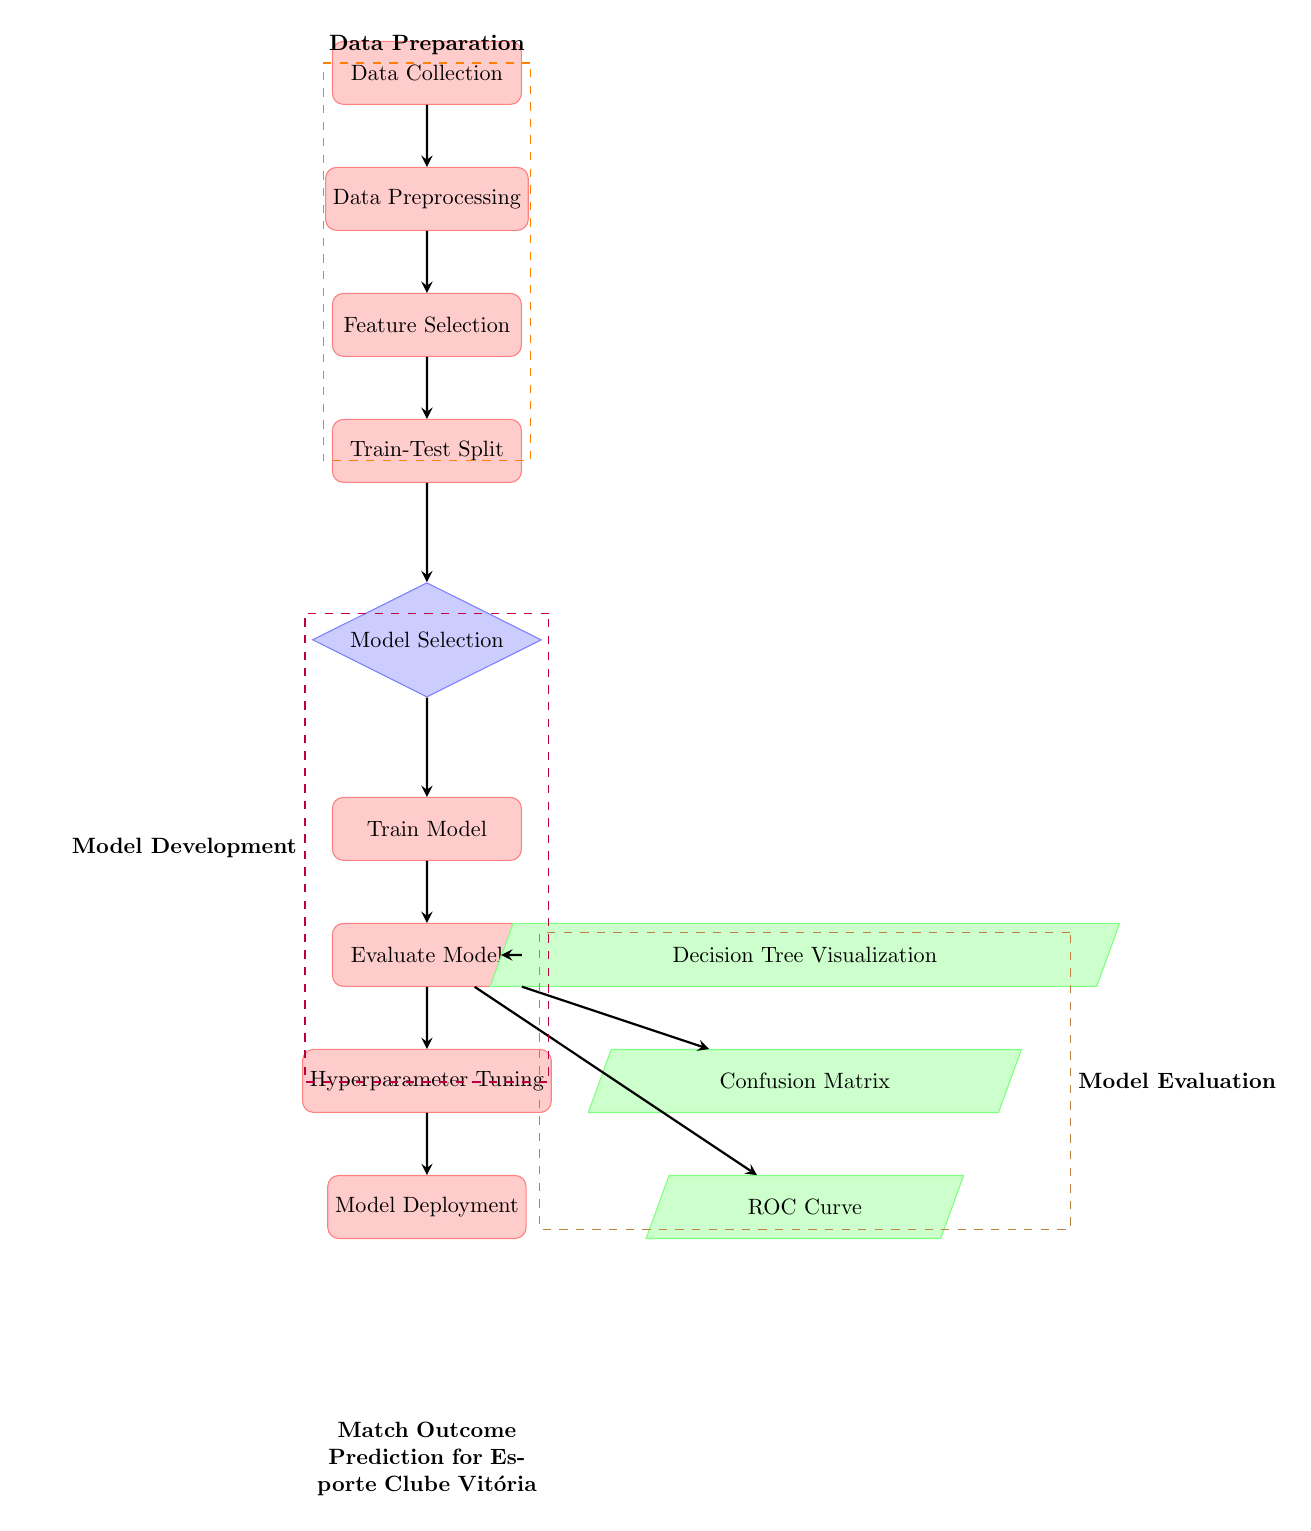What is the first process in the diagram? The first node in the diagram is labeled "Data Collection," which indicates it is the starting point of the machine learning pipeline.
Answer: Data Collection How many output nodes are there? In the diagram, there are three output nodes: "Decision Tree Visualization," "Confusion Matrix," and "ROC Curve." This can be counted directly from the nodes positioned to the right of the main process flow.
Answer: Three What follows after "Evaluate Model"? The node that follows "Evaluate Model" directly downwards is labeled "Hyperparameter Tuning," which indicates the next step in enhancing the model based on evaluation results.
Answer: Hyperparameter Tuning Which nodes are part of the Data Preparation grouping? The nodes inside the dashed orange box labeled "Data Preparation" include "Data Collection," "Data Preprocessing," "Feature Selection," and "Train-Test Split." This grouping is visually represented on the left side of the diagram.
Answer: Data Collection, Data Preprocessing, Feature Selection, Train-Test Split What is the last step of the Model Development phase? The last process in the "Model Development" grouping, marked by the dashed purple box, is "Hyperparameter Tuning," which signifies final adjustments before deployment.
Answer: Hyperparameter Tuning Which output node relates to the visualization of model decision-making? The output node labeled "Decision Tree Visualization" relates specifically to the graphical interpretation of how the model makes decisions based on the features provided in the training phase.
Answer: Decision Tree Visualization What indicates the transition between data preparation and model development? The transition from the data preparation phase to model development is indicated by a downward arrow leading from the last data preparation step, "Train-Test Split," to the model selection step labeled "Model Selection."
Answer: Model Selection How many dashed boxes are present in the diagram? There are three dashed boxes: one for "Data Preparation," one for "Model Development," and one for "Model Evaluation" surrounding their respective nodes. This can be observed by counting the grouped visual elements.
Answer: Three 